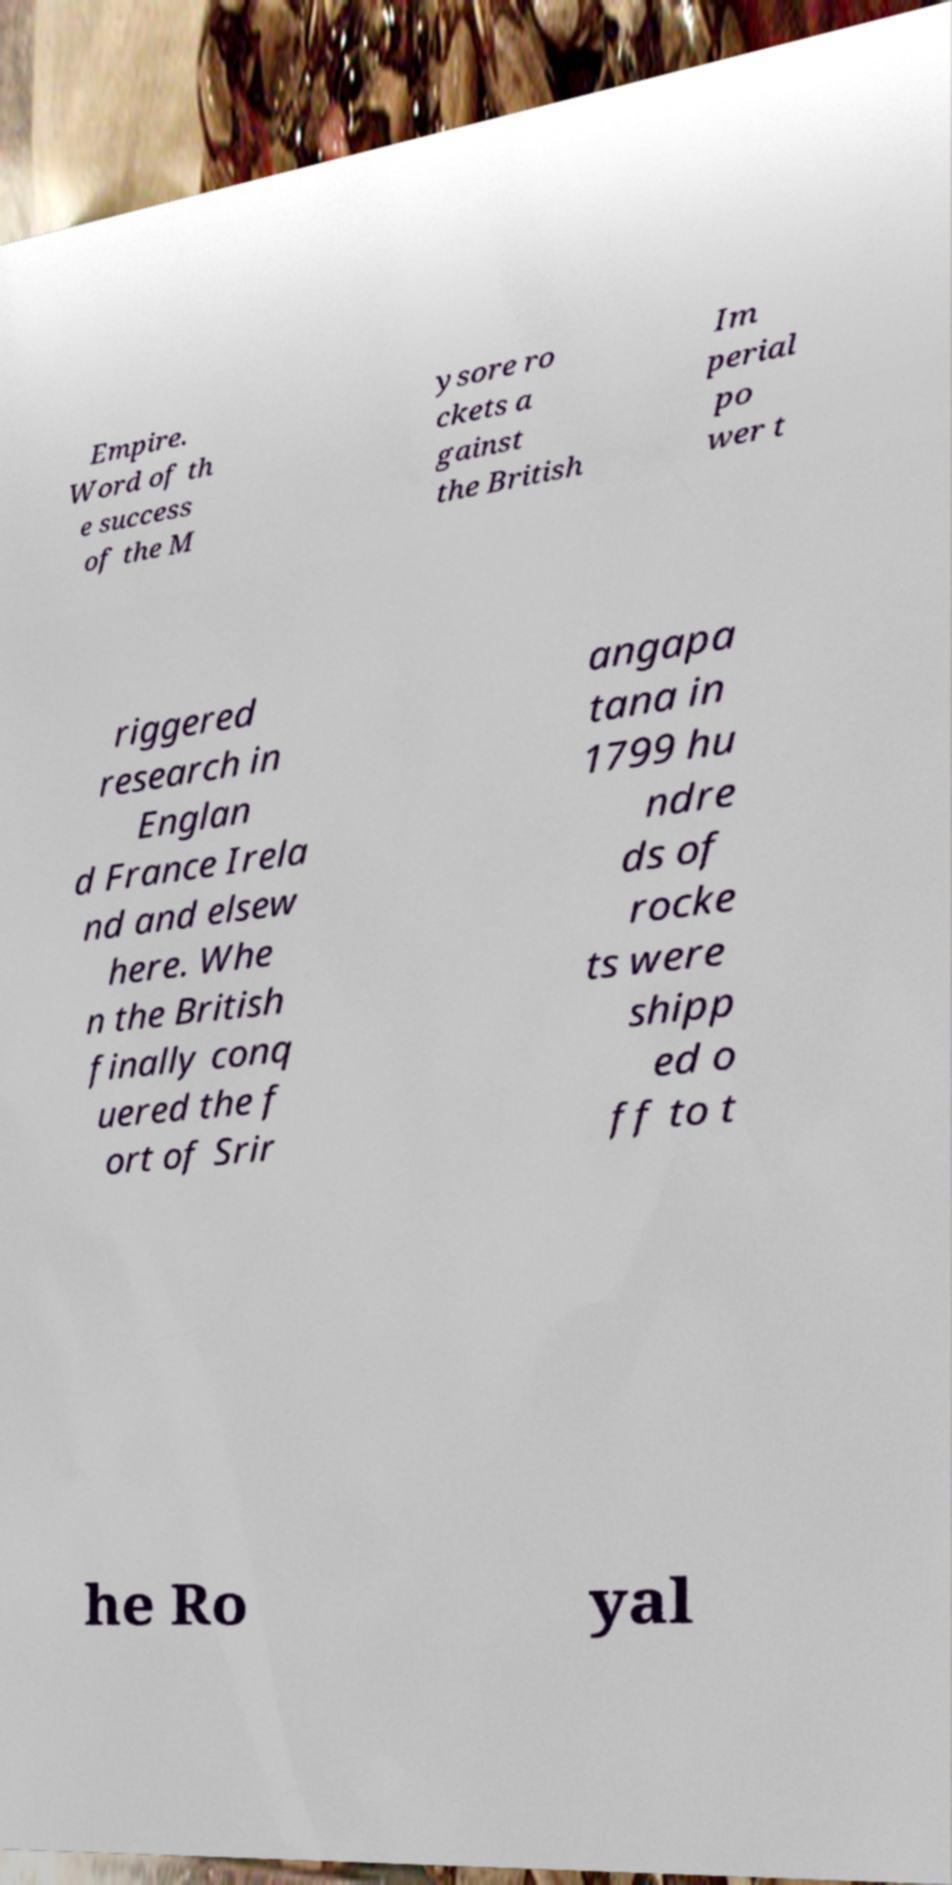For documentation purposes, I need the text within this image transcribed. Could you provide that? Empire. Word of th e success of the M ysore ro ckets a gainst the British Im perial po wer t riggered research in Englan d France Irela nd and elsew here. Whe n the British finally conq uered the f ort of Srir angapa tana in 1799 hu ndre ds of rocke ts were shipp ed o ff to t he Ro yal 